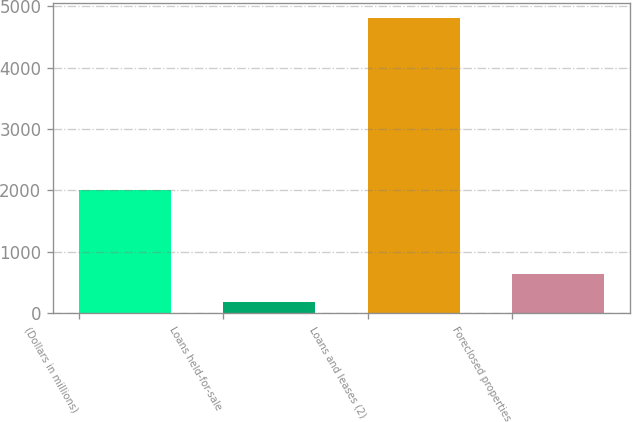Convert chart to OTSL. <chart><loc_0><loc_0><loc_500><loc_500><bar_chart><fcel>(Dollars in millions)<fcel>Loans held-for-sale<fcel>Loans and leases (2)<fcel>Foreclosed properties<nl><fcel>2011<fcel>181<fcel>4813<fcel>644.2<nl></chart> 